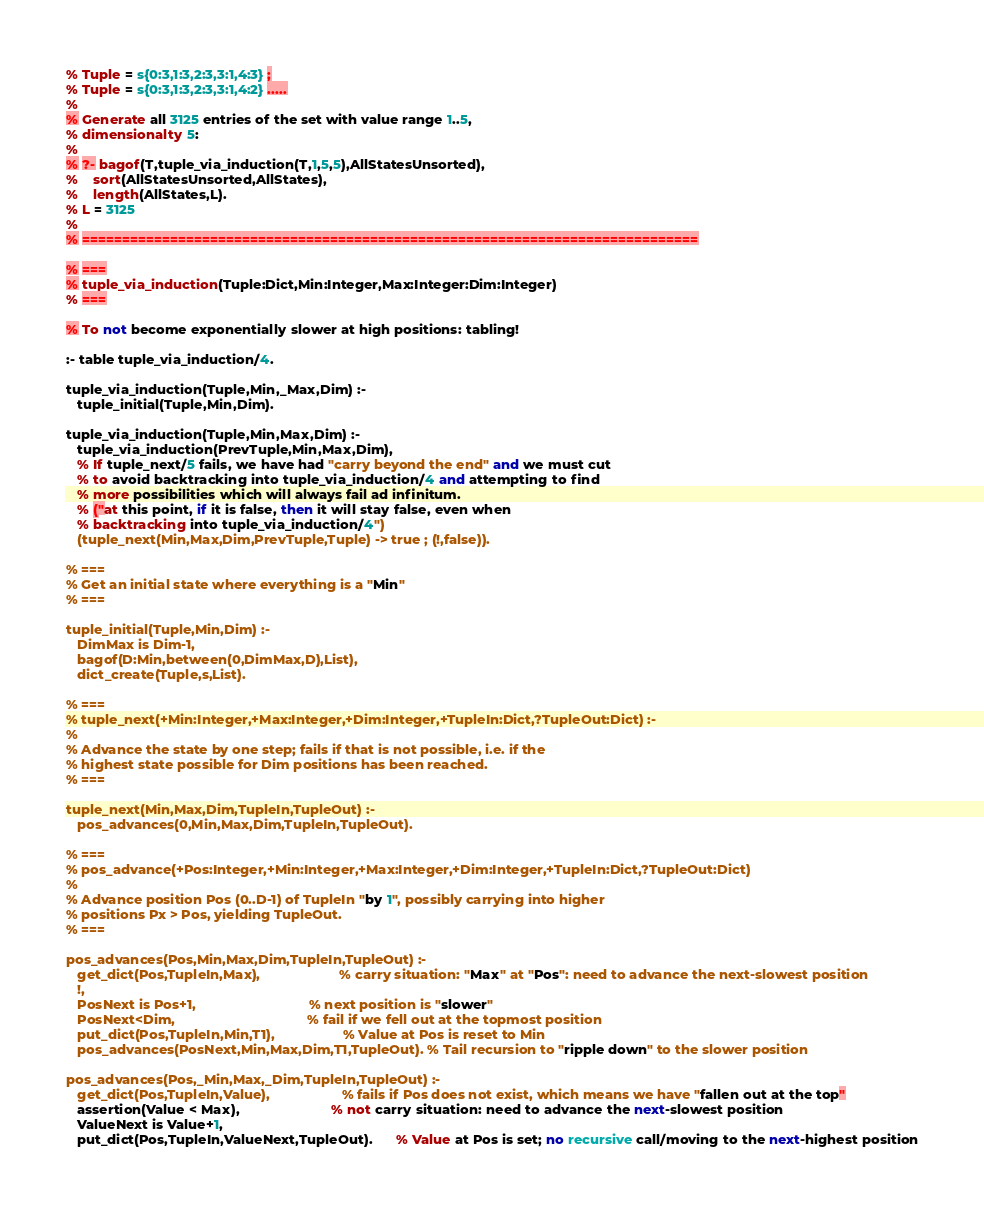Convert code to text. <code><loc_0><loc_0><loc_500><loc_500><_Perl_>% Tuple = s{0:3,1:3,2:3,3:1,4:3} ;
% Tuple = s{0:3,1:3,2:3,3:1,4:2} .....
% 
% Generate all 3125 entries of the set with value range 1..5, 
% dimensionalty 5:
%
% ?- bagof(T,tuple_via_induction(T,1,5,5),AllStatesUnsorted),
%    sort(AllStatesUnsorted,AllStates),
%    length(AllStates,L).
% L = 3125
%
% =============================================================================

% ===
% tuple_via_induction(Tuple:Dict,Min:Integer,Max:Integer:Dim:Integer)
% ===

% To not become exponentially slower at high positions: tabling!

:- table tuple_via_induction/4.

tuple_via_induction(Tuple,Min,_Max,Dim) :-
   tuple_initial(Tuple,Min,Dim).

tuple_via_induction(Tuple,Min,Max,Dim) :-
   tuple_via_induction(PrevTuple,Min,Max,Dim),
   % If tuple_next/5 fails, we have had "carry beyond the end" and we must cut
   % to avoid backtracking into tuple_via_induction/4 and attempting to find
   % more possibilities which will always fail ad infinitum.
   % ("at this point, if it is false, then it will stay false, even when
   % backtracking into tuple_via_induction/4")
   (tuple_next(Min,Max,Dim,PrevTuple,Tuple) -> true ; (!,false)).

% ===
% Get an initial state where everything is a "Min"
% ===

tuple_initial(Tuple,Min,Dim) :-
   DimMax is Dim-1,
   bagof(D:Min,between(0,DimMax,D),List),
   dict_create(Tuple,s,List).

% ===
% tuple_next(+Min:Integer,+Max:Integer,+Dim:Integer,+TupleIn:Dict,?TupleOut:Dict) :-
%
% Advance the state by one step; fails if that is not possible, i.e. if the
% highest state possible for Dim positions has been reached.
% ===

tuple_next(Min,Max,Dim,TupleIn,TupleOut) :-
   pos_advances(0,Min,Max,Dim,TupleIn,TupleOut).

% ===
% pos_advance(+Pos:Integer,+Min:Integer,+Max:Integer,+Dim:Integer,+TupleIn:Dict,?TupleOut:Dict)
%
% Advance position Pos (0..D-1) of TupleIn "by 1", possibly carrying into higher
% positions Px > Pos, yielding TupleOut.
% ===

pos_advances(Pos,Min,Max,Dim,TupleIn,TupleOut) :-
   get_dict(Pos,TupleIn,Max),                     % carry situation: "Max" at "Pos": need to advance the next-slowest position
   !,
   PosNext is Pos+1,                              % next position is "slower"
   PosNext<Dim,                                   % fail if we fell out at the topmost position
   put_dict(Pos,TupleIn,Min,T1),                  % Value at Pos is reset to Min
   pos_advances(PosNext,Min,Max,Dim,T1,TupleOut). % Tail recursion to "ripple down" to the slower position

pos_advances(Pos,_Min,Max,_Dim,TupleIn,TupleOut) :-
   get_dict(Pos,TupleIn,Value),                   % fails if Pos does not exist, which means we have "fallen out at the top"
   assertion(Value < Max),                        % not carry situation: need to advance the next-slowest position
   ValueNext is Value+1,
   put_dict(Pos,TupleIn,ValueNext,TupleOut).      % Value at Pos is set; no recursive call/moving to the next-highest position

</code> 